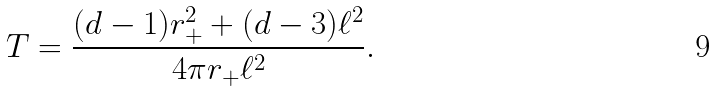<formula> <loc_0><loc_0><loc_500><loc_500>T = \frac { ( d - 1 ) r _ { + } ^ { 2 } + ( d - 3 ) \ell ^ { 2 } } { 4 \pi r _ { + } \ell ^ { 2 } } .</formula> 